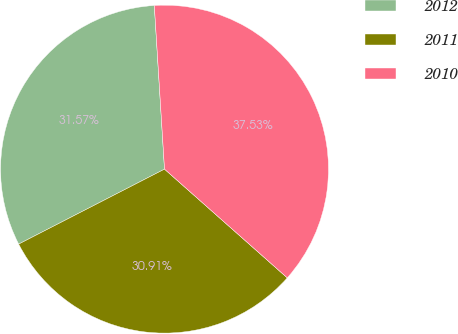Convert chart. <chart><loc_0><loc_0><loc_500><loc_500><pie_chart><fcel>2012<fcel>2011<fcel>2010<nl><fcel>31.57%<fcel>30.91%<fcel>37.53%<nl></chart> 